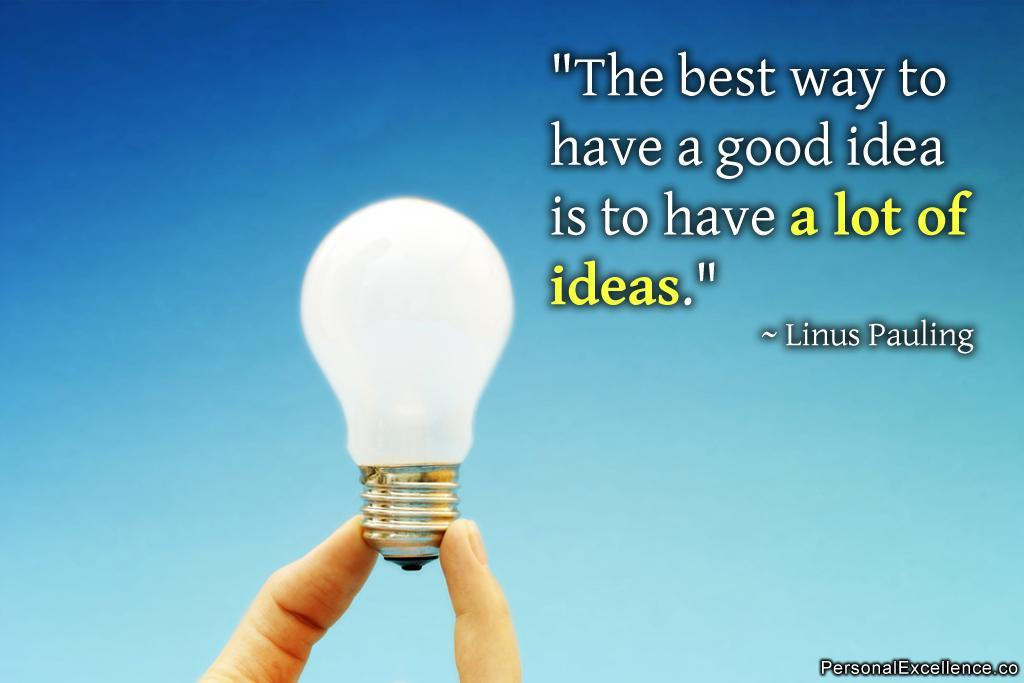What is the main subject of the poster in the image? The poster contains an image of human fingers holding a bulb. What else can be seen on the poster besides the image? There is text present on the poster. Can you see any grapes or umbrellas at the seashore in the image? There is no seashore, grapes, or umbrellas present in the image. The image only features a poster with an image of human fingers holding a bulb and accompanying text. 